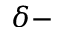<formula> <loc_0><loc_0><loc_500><loc_500>\delta -</formula> 